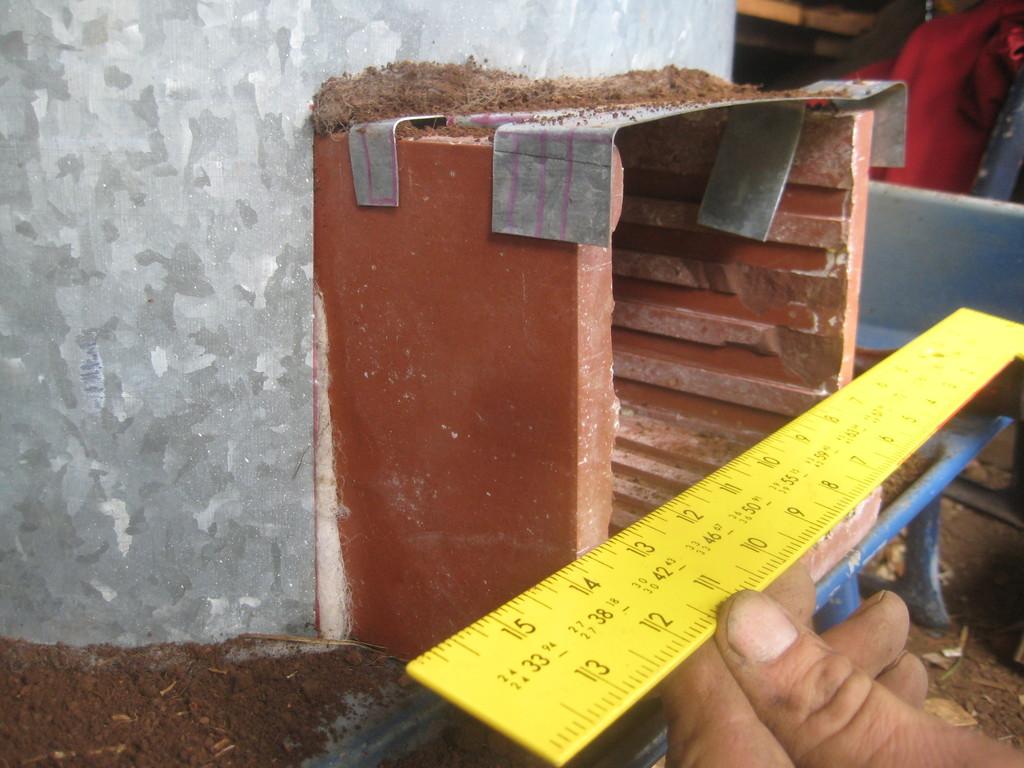Does this ruler have 1/3 on it?
Provide a succinct answer. Yes. Are the numbers on this ruler black?
Your answer should be compact. Yes. 